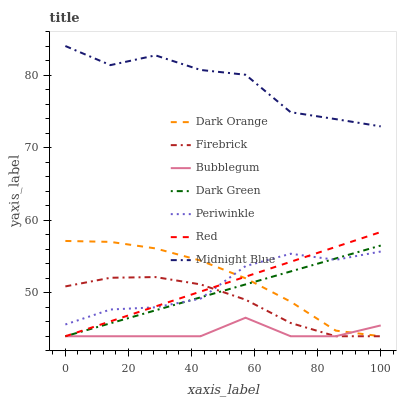Does Firebrick have the minimum area under the curve?
Answer yes or no. No. Does Firebrick have the maximum area under the curve?
Answer yes or no. No. Is Firebrick the smoothest?
Answer yes or no. No. Is Firebrick the roughest?
Answer yes or no. No. Does Midnight Blue have the lowest value?
Answer yes or no. No. Does Firebrick have the highest value?
Answer yes or no. No. Is Dark Green less than Midnight Blue?
Answer yes or no. Yes. Is Midnight Blue greater than Red?
Answer yes or no. Yes. Does Dark Green intersect Midnight Blue?
Answer yes or no. No. 